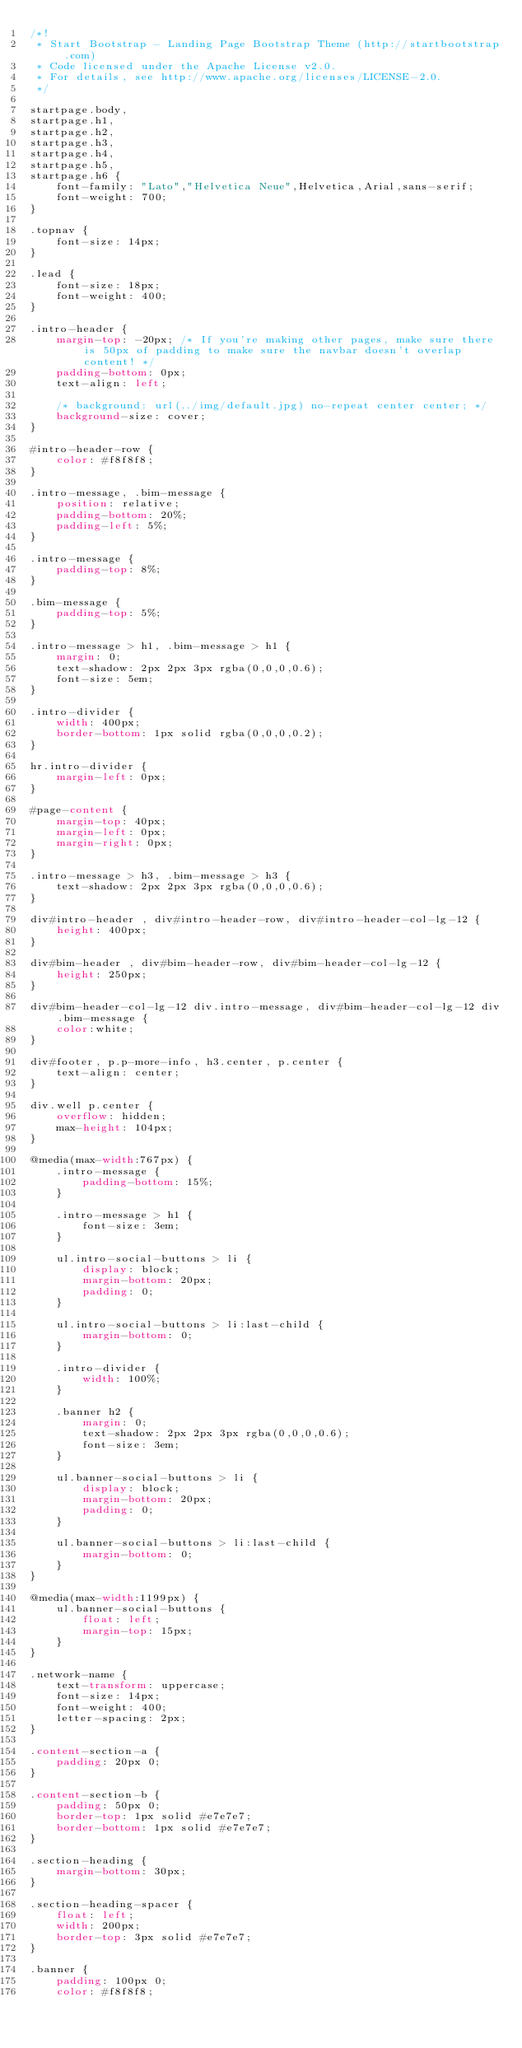Convert code to text. <code><loc_0><loc_0><loc_500><loc_500><_CSS_>/*!
 * Start Bootstrap - Landing Page Bootstrap Theme (http://startbootstrap.com)
 * Code licensed under the Apache License v2.0.
 * For details, see http://www.apache.org/licenses/LICENSE-2.0.
 */

startpage.body,
startpage.h1,
startpage.h2,
startpage.h3,
startpage.h4,
startpage.h5,
startpage.h6 {
    font-family: "Lato","Helvetica Neue",Helvetica,Arial,sans-serif;
    font-weight: 700;
}

.topnav {
    font-size: 14px;
}

.lead {
    font-size: 18px;
    font-weight: 400;
}

.intro-header {
    margin-top: -20px; /* If you're making other pages, make sure there is 50px of padding to make sure the navbar doesn't overlap content! */
    padding-bottom: 0px;
    text-align: left;

    /* background: url(../img/default.jpg) no-repeat center center; */
    background-size: cover;
}

#intro-header-row {
    color: #f8f8f8;
}

.intro-message, .bim-message {
	position: relative;
	padding-bottom: 20%;
	padding-left: 5%;
}

.intro-message {
	padding-top: 8%;
}

.bim-message {
	padding-top: 5%;
}

.intro-message > h1, .bim-message > h1 {
	margin: 0;
	text-shadow: 2px 2px 3px rgba(0,0,0,0.6);
	font-size: 5em;
}

.intro-divider {
	width: 400px;
	border-bottom: 1px solid rgba(0,0,0,0.2);
}

hr.intro-divider {
	margin-left: 0px;
}

#page-content {
	margin-top: 40px;
	margin-left: 0px;
	margin-right: 0px;
}

.intro-message > h3, .bim-message > h3 {
	text-shadow: 2px 2px 3px rgba(0,0,0,0.6);
}

div#intro-header , div#intro-header-row, div#intro-header-col-lg-12 {
	height: 400px;
}

div#bim-header , div#bim-header-row, div#bim-header-col-lg-12 {
	height: 250px;
}

div#bim-header-col-lg-12 div.intro-message, div#bim-header-col-lg-12 div.bim-message {
	color:white;
}

div#footer, p.p-more-info, h3.center, p.center {
	text-align: center;
}

div.well p.center {
	overflow: hidden;
	max-height: 104px;
}

@media(max-width:767px) {
	.intro-message {
		padding-bottom: 15%;
	}

	.intro-message > h1 {
		font-size: 3em;
	}

	ul.intro-social-buttons > li {
		display: block;
		margin-bottom: 20px;
		padding: 0;
	}

	ul.intro-social-buttons > li:last-child {
		margin-bottom: 0;
	}

	.intro-divider {
		width: 100%;
	}

	.banner h2 {
		margin: 0;
		text-shadow: 2px 2px 3px rgba(0,0,0,0.6);
		font-size: 3em;
	}

	ul.banner-social-buttons > li {
		display: block;
		margin-bottom: 20px;
		padding: 0;
	}

	ul.banner-social-buttons > li:last-child {
		margin-bottom: 0;
	}
}

@media(max-width:1199px) {
	ul.banner-social-buttons {
		float: left;
		margin-top: 15px;
	}
}

.network-name {
	text-transform: uppercase;
	font-size: 14px;
	font-weight: 400;
	letter-spacing: 2px;
}

.content-section-a {
	padding: 20px 0;
}

.content-section-b {
	padding: 50px 0;
	border-top: 1px solid #e7e7e7;
	border-bottom: 1px solid #e7e7e7;
}

.section-heading {
	margin-bottom: 30px;
}

.section-heading-spacer {
	float: left;
	width: 200px;
	border-top: 3px solid #e7e7e7;
}

.banner {
	padding: 100px 0;
	color: #f8f8f8;</code> 